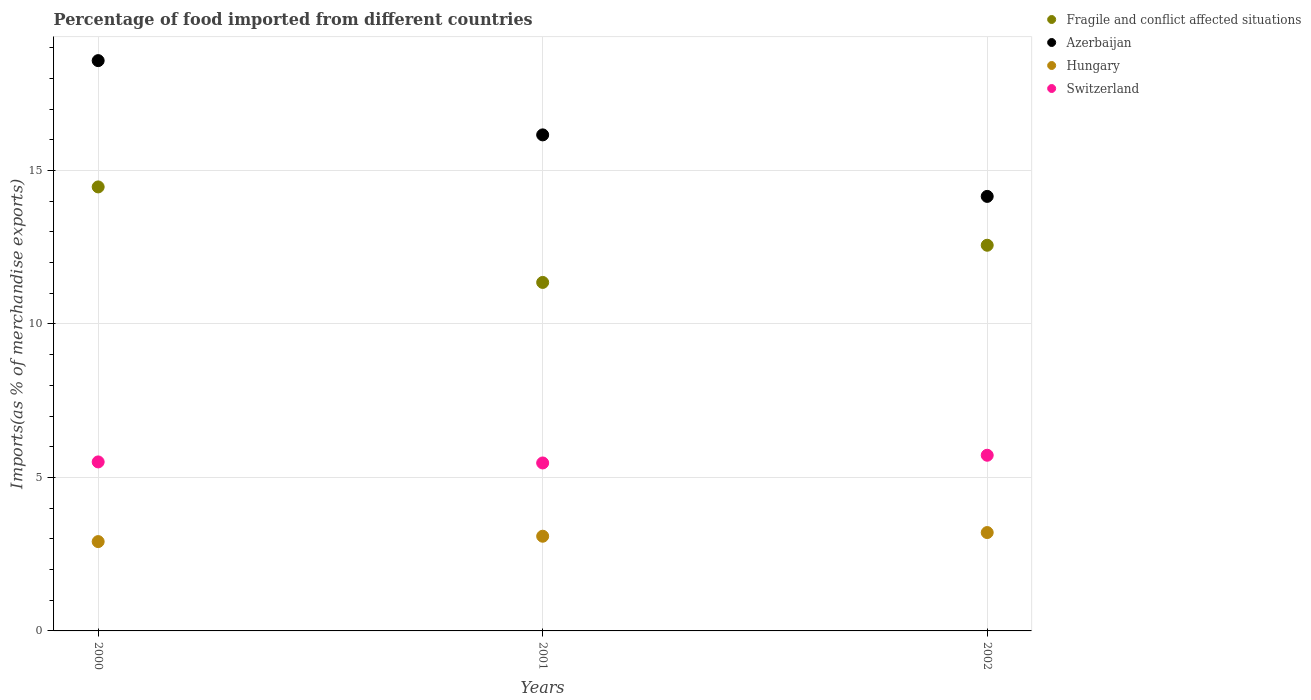How many different coloured dotlines are there?
Give a very brief answer. 4. Is the number of dotlines equal to the number of legend labels?
Provide a succinct answer. Yes. What is the percentage of imports to different countries in Hungary in 2000?
Offer a very short reply. 2.91. Across all years, what is the maximum percentage of imports to different countries in Switzerland?
Keep it short and to the point. 5.72. Across all years, what is the minimum percentage of imports to different countries in Switzerland?
Offer a very short reply. 5.47. In which year was the percentage of imports to different countries in Switzerland maximum?
Offer a very short reply. 2002. In which year was the percentage of imports to different countries in Azerbaijan minimum?
Offer a terse response. 2002. What is the total percentage of imports to different countries in Fragile and conflict affected situations in the graph?
Your response must be concise. 38.38. What is the difference between the percentage of imports to different countries in Hungary in 2000 and that in 2001?
Ensure brevity in your answer.  -0.17. What is the difference between the percentage of imports to different countries in Switzerland in 2002 and the percentage of imports to different countries in Fragile and conflict affected situations in 2000?
Provide a short and direct response. -8.74. What is the average percentage of imports to different countries in Fragile and conflict affected situations per year?
Offer a very short reply. 12.79. In the year 2000, what is the difference between the percentage of imports to different countries in Hungary and percentage of imports to different countries in Fragile and conflict affected situations?
Offer a very short reply. -11.55. In how many years, is the percentage of imports to different countries in Switzerland greater than 10 %?
Your answer should be very brief. 0. What is the ratio of the percentage of imports to different countries in Switzerland in 2001 to that in 2002?
Ensure brevity in your answer.  0.96. Is the percentage of imports to different countries in Fragile and conflict affected situations in 2000 less than that in 2002?
Your answer should be compact. No. Is the difference between the percentage of imports to different countries in Hungary in 2000 and 2001 greater than the difference between the percentage of imports to different countries in Fragile and conflict affected situations in 2000 and 2001?
Keep it short and to the point. No. What is the difference between the highest and the second highest percentage of imports to different countries in Switzerland?
Provide a succinct answer. 0.22. What is the difference between the highest and the lowest percentage of imports to different countries in Fragile and conflict affected situations?
Offer a very short reply. 3.11. Is the percentage of imports to different countries in Azerbaijan strictly greater than the percentage of imports to different countries in Hungary over the years?
Your answer should be very brief. Yes. Is the percentage of imports to different countries in Azerbaijan strictly less than the percentage of imports to different countries in Switzerland over the years?
Your answer should be very brief. No. How many dotlines are there?
Offer a terse response. 4. What is the difference between two consecutive major ticks on the Y-axis?
Your answer should be very brief. 5. Are the values on the major ticks of Y-axis written in scientific E-notation?
Offer a terse response. No. Does the graph contain grids?
Give a very brief answer. Yes. How many legend labels are there?
Offer a very short reply. 4. What is the title of the graph?
Give a very brief answer. Percentage of food imported from different countries. Does "Lao PDR" appear as one of the legend labels in the graph?
Your answer should be very brief. No. What is the label or title of the X-axis?
Your answer should be very brief. Years. What is the label or title of the Y-axis?
Ensure brevity in your answer.  Imports(as % of merchandise exports). What is the Imports(as % of merchandise exports) of Fragile and conflict affected situations in 2000?
Make the answer very short. 14.46. What is the Imports(as % of merchandise exports) in Azerbaijan in 2000?
Offer a terse response. 18.58. What is the Imports(as % of merchandise exports) of Hungary in 2000?
Make the answer very short. 2.91. What is the Imports(as % of merchandise exports) in Switzerland in 2000?
Your answer should be very brief. 5.5. What is the Imports(as % of merchandise exports) in Fragile and conflict affected situations in 2001?
Make the answer very short. 11.35. What is the Imports(as % of merchandise exports) in Azerbaijan in 2001?
Give a very brief answer. 16.16. What is the Imports(as % of merchandise exports) of Hungary in 2001?
Make the answer very short. 3.08. What is the Imports(as % of merchandise exports) in Switzerland in 2001?
Offer a terse response. 5.47. What is the Imports(as % of merchandise exports) in Fragile and conflict affected situations in 2002?
Your answer should be compact. 12.56. What is the Imports(as % of merchandise exports) of Azerbaijan in 2002?
Make the answer very short. 14.15. What is the Imports(as % of merchandise exports) of Hungary in 2002?
Give a very brief answer. 3.2. What is the Imports(as % of merchandise exports) in Switzerland in 2002?
Ensure brevity in your answer.  5.72. Across all years, what is the maximum Imports(as % of merchandise exports) of Fragile and conflict affected situations?
Your response must be concise. 14.46. Across all years, what is the maximum Imports(as % of merchandise exports) of Azerbaijan?
Offer a very short reply. 18.58. Across all years, what is the maximum Imports(as % of merchandise exports) in Hungary?
Provide a succinct answer. 3.2. Across all years, what is the maximum Imports(as % of merchandise exports) in Switzerland?
Keep it short and to the point. 5.72. Across all years, what is the minimum Imports(as % of merchandise exports) of Fragile and conflict affected situations?
Your answer should be very brief. 11.35. Across all years, what is the minimum Imports(as % of merchandise exports) of Azerbaijan?
Make the answer very short. 14.15. Across all years, what is the minimum Imports(as % of merchandise exports) in Hungary?
Give a very brief answer. 2.91. Across all years, what is the minimum Imports(as % of merchandise exports) in Switzerland?
Provide a succinct answer. 5.47. What is the total Imports(as % of merchandise exports) in Fragile and conflict affected situations in the graph?
Your answer should be compact. 38.38. What is the total Imports(as % of merchandise exports) in Azerbaijan in the graph?
Provide a succinct answer. 48.89. What is the total Imports(as % of merchandise exports) of Hungary in the graph?
Keep it short and to the point. 9.2. What is the total Imports(as % of merchandise exports) of Switzerland in the graph?
Give a very brief answer. 16.7. What is the difference between the Imports(as % of merchandise exports) of Fragile and conflict affected situations in 2000 and that in 2001?
Your answer should be compact. 3.11. What is the difference between the Imports(as % of merchandise exports) of Azerbaijan in 2000 and that in 2001?
Provide a short and direct response. 2.42. What is the difference between the Imports(as % of merchandise exports) in Hungary in 2000 and that in 2001?
Provide a short and direct response. -0.17. What is the difference between the Imports(as % of merchandise exports) of Switzerland in 2000 and that in 2001?
Keep it short and to the point. 0.03. What is the difference between the Imports(as % of merchandise exports) in Fragile and conflict affected situations in 2000 and that in 2002?
Provide a short and direct response. 1.9. What is the difference between the Imports(as % of merchandise exports) of Azerbaijan in 2000 and that in 2002?
Your response must be concise. 4.42. What is the difference between the Imports(as % of merchandise exports) of Hungary in 2000 and that in 2002?
Your answer should be very brief. -0.29. What is the difference between the Imports(as % of merchandise exports) of Switzerland in 2000 and that in 2002?
Your answer should be compact. -0.22. What is the difference between the Imports(as % of merchandise exports) in Fragile and conflict affected situations in 2001 and that in 2002?
Provide a succinct answer. -1.21. What is the difference between the Imports(as % of merchandise exports) in Azerbaijan in 2001 and that in 2002?
Provide a succinct answer. 2. What is the difference between the Imports(as % of merchandise exports) of Hungary in 2001 and that in 2002?
Ensure brevity in your answer.  -0.12. What is the difference between the Imports(as % of merchandise exports) in Switzerland in 2001 and that in 2002?
Make the answer very short. -0.25. What is the difference between the Imports(as % of merchandise exports) of Fragile and conflict affected situations in 2000 and the Imports(as % of merchandise exports) of Azerbaijan in 2001?
Offer a very short reply. -1.7. What is the difference between the Imports(as % of merchandise exports) of Fragile and conflict affected situations in 2000 and the Imports(as % of merchandise exports) of Hungary in 2001?
Provide a short and direct response. 11.38. What is the difference between the Imports(as % of merchandise exports) in Fragile and conflict affected situations in 2000 and the Imports(as % of merchandise exports) in Switzerland in 2001?
Offer a very short reply. 8.99. What is the difference between the Imports(as % of merchandise exports) in Azerbaijan in 2000 and the Imports(as % of merchandise exports) in Hungary in 2001?
Make the answer very short. 15.49. What is the difference between the Imports(as % of merchandise exports) in Azerbaijan in 2000 and the Imports(as % of merchandise exports) in Switzerland in 2001?
Provide a succinct answer. 13.1. What is the difference between the Imports(as % of merchandise exports) in Hungary in 2000 and the Imports(as % of merchandise exports) in Switzerland in 2001?
Your response must be concise. -2.56. What is the difference between the Imports(as % of merchandise exports) in Fragile and conflict affected situations in 2000 and the Imports(as % of merchandise exports) in Azerbaijan in 2002?
Your answer should be compact. 0.31. What is the difference between the Imports(as % of merchandise exports) of Fragile and conflict affected situations in 2000 and the Imports(as % of merchandise exports) of Hungary in 2002?
Keep it short and to the point. 11.26. What is the difference between the Imports(as % of merchandise exports) in Fragile and conflict affected situations in 2000 and the Imports(as % of merchandise exports) in Switzerland in 2002?
Your answer should be very brief. 8.74. What is the difference between the Imports(as % of merchandise exports) of Azerbaijan in 2000 and the Imports(as % of merchandise exports) of Hungary in 2002?
Give a very brief answer. 15.37. What is the difference between the Imports(as % of merchandise exports) in Azerbaijan in 2000 and the Imports(as % of merchandise exports) in Switzerland in 2002?
Offer a very short reply. 12.85. What is the difference between the Imports(as % of merchandise exports) in Hungary in 2000 and the Imports(as % of merchandise exports) in Switzerland in 2002?
Your answer should be compact. -2.81. What is the difference between the Imports(as % of merchandise exports) in Fragile and conflict affected situations in 2001 and the Imports(as % of merchandise exports) in Azerbaijan in 2002?
Provide a succinct answer. -2.8. What is the difference between the Imports(as % of merchandise exports) in Fragile and conflict affected situations in 2001 and the Imports(as % of merchandise exports) in Hungary in 2002?
Provide a short and direct response. 8.15. What is the difference between the Imports(as % of merchandise exports) of Fragile and conflict affected situations in 2001 and the Imports(as % of merchandise exports) of Switzerland in 2002?
Your response must be concise. 5.63. What is the difference between the Imports(as % of merchandise exports) in Azerbaijan in 2001 and the Imports(as % of merchandise exports) in Hungary in 2002?
Provide a short and direct response. 12.95. What is the difference between the Imports(as % of merchandise exports) of Azerbaijan in 2001 and the Imports(as % of merchandise exports) of Switzerland in 2002?
Ensure brevity in your answer.  10.44. What is the difference between the Imports(as % of merchandise exports) in Hungary in 2001 and the Imports(as % of merchandise exports) in Switzerland in 2002?
Keep it short and to the point. -2.64. What is the average Imports(as % of merchandise exports) of Fragile and conflict affected situations per year?
Provide a succinct answer. 12.79. What is the average Imports(as % of merchandise exports) of Azerbaijan per year?
Make the answer very short. 16.3. What is the average Imports(as % of merchandise exports) in Hungary per year?
Make the answer very short. 3.07. What is the average Imports(as % of merchandise exports) of Switzerland per year?
Provide a short and direct response. 5.57. In the year 2000, what is the difference between the Imports(as % of merchandise exports) in Fragile and conflict affected situations and Imports(as % of merchandise exports) in Azerbaijan?
Make the answer very short. -4.11. In the year 2000, what is the difference between the Imports(as % of merchandise exports) in Fragile and conflict affected situations and Imports(as % of merchandise exports) in Hungary?
Provide a succinct answer. 11.55. In the year 2000, what is the difference between the Imports(as % of merchandise exports) of Fragile and conflict affected situations and Imports(as % of merchandise exports) of Switzerland?
Offer a very short reply. 8.96. In the year 2000, what is the difference between the Imports(as % of merchandise exports) of Azerbaijan and Imports(as % of merchandise exports) of Hungary?
Ensure brevity in your answer.  15.67. In the year 2000, what is the difference between the Imports(as % of merchandise exports) of Azerbaijan and Imports(as % of merchandise exports) of Switzerland?
Offer a terse response. 13.07. In the year 2000, what is the difference between the Imports(as % of merchandise exports) in Hungary and Imports(as % of merchandise exports) in Switzerland?
Ensure brevity in your answer.  -2.6. In the year 2001, what is the difference between the Imports(as % of merchandise exports) in Fragile and conflict affected situations and Imports(as % of merchandise exports) in Azerbaijan?
Your answer should be very brief. -4.81. In the year 2001, what is the difference between the Imports(as % of merchandise exports) in Fragile and conflict affected situations and Imports(as % of merchandise exports) in Hungary?
Offer a very short reply. 8.27. In the year 2001, what is the difference between the Imports(as % of merchandise exports) of Fragile and conflict affected situations and Imports(as % of merchandise exports) of Switzerland?
Your answer should be compact. 5.88. In the year 2001, what is the difference between the Imports(as % of merchandise exports) in Azerbaijan and Imports(as % of merchandise exports) in Hungary?
Ensure brevity in your answer.  13.07. In the year 2001, what is the difference between the Imports(as % of merchandise exports) of Azerbaijan and Imports(as % of merchandise exports) of Switzerland?
Offer a very short reply. 10.69. In the year 2001, what is the difference between the Imports(as % of merchandise exports) of Hungary and Imports(as % of merchandise exports) of Switzerland?
Make the answer very short. -2.39. In the year 2002, what is the difference between the Imports(as % of merchandise exports) in Fragile and conflict affected situations and Imports(as % of merchandise exports) in Azerbaijan?
Provide a short and direct response. -1.59. In the year 2002, what is the difference between the Imports(as % of merchandise exports) in Fragile and conflict affected situations and Imports(as % of merchandise exports) in Hungary?
Keep it short and to the point. 9.36. In the year 2002, what is the difference between the Imports(as % of merchandise exports) of Fragile and conflict affected situations and Imports(as % of merchandise exports) of Switzerland?
Offer a very short reply. 6.84. In the year 2002, what is the difference between the Imports(as % of merchandise exports) of Azerbaijan and Imports(as % of merchandise exports) of Hungary?
Your answer should be compact. 10.95. In the year 2002, what is the difference between the Imports(as % of merchandise exports) in Azerbaijan and Imports(as % of merchandise exports) in Switzerland?
Provide a short and direct response. 8.43. In the year 2002, what is the difference between the Imports(as % of merchandise exports) in Hungary and Imports(as % of merchandise exports) in Switzerland?
Your answer should be very brief. -2.52. What is the ratio of the Imports(as % of merchandise exports) of Fragile and conflict affected situations in 2000 to that in 2001?
Offer a very short reply. 1.27. What is the ratio of the Imports(as % of merchandise exports) in Azerbaijan in 2000 to that in 2001?
Offer a terse response. 1.15. What is the ratio of the Imports(as % of merchandise exports) in Hungary in 2000 to that in 2001?
Your answer should be compact. 0.94. What is the ratio of the Imports(as % of merchandise exports) of Switzerland in 2000 to that in 2001?
Make the answer very short. 1.01. What is the ratio of the Imports(as % of merchandise exports) in Fragile and conflict affected situations in 2000 to that in 2002?
Offer a terse response. 1.15. What is the ratio of the Imports(as % of merchandise exports) of Azerbaijan in 2000 to that in 2002?
Your answer should be compact. 1.31. What is the ratio of the Imports(as % of merchandise exports) in Hungary in 2000 to that in 2002?
Keep it short and to the point. 0.91. What is the ratio of the Imports(as % of merchandise exports) in Fragile and conflict affected situations in 2001 to that in 2002?
Your response must be concise. 0.9. What is the ratio of the Imports(as % of merchandise exports) of Azerbaijan in 2001 to that in 2002?
Keep it short and to the point. 1.14. What is the ratio of the Imports(as % of merchandise exports) in Hungary in 2001 to that in 2002?
Your response must be concise. 0.96. What is the ratio of the Imports(as % of merchandise exports) in Switzerland in 2001 to that in 2002?
Your response must be concise. 0.96. What is the difference between the highest and the second highest Imports(as % of merchandise exports) in Fragile and conflict affected situations?
Your response must be concise. 1.9. What is the difference between the highest and the second highest Imports(as % of merchandise exports) of Azerbaijan?
Provide a succinct answer. 2.42. What is the difference between the highest and the second highest Imports(as % of merchandise exports) in Hungary?
Your answer should be compact. 0.12. What is the difference between the highest and the second highest Imports(as % of merchandise exports) of Switzerland?
Ensure brevity in your answer.  0.22. What is the difference between the highest and the lowest Imports(as % of merchandise exports) in Fragile and conflict affected situations?
Offer a terse response. 3.11. What is the difference between the highest and the lowest Imports(as % of merchandise exports) in Azerbaijan?
Your answer should be compact. 4.42. What is the difference between the highest and the lowest Imports(as % of merchandise exports) in Hungary?
Provide a succinct answer. 0.29. What is the difference between the highest and the lowest Imports(as % of merchandise exports) of Switzerland?
Your answer should be compact. 0.25. 